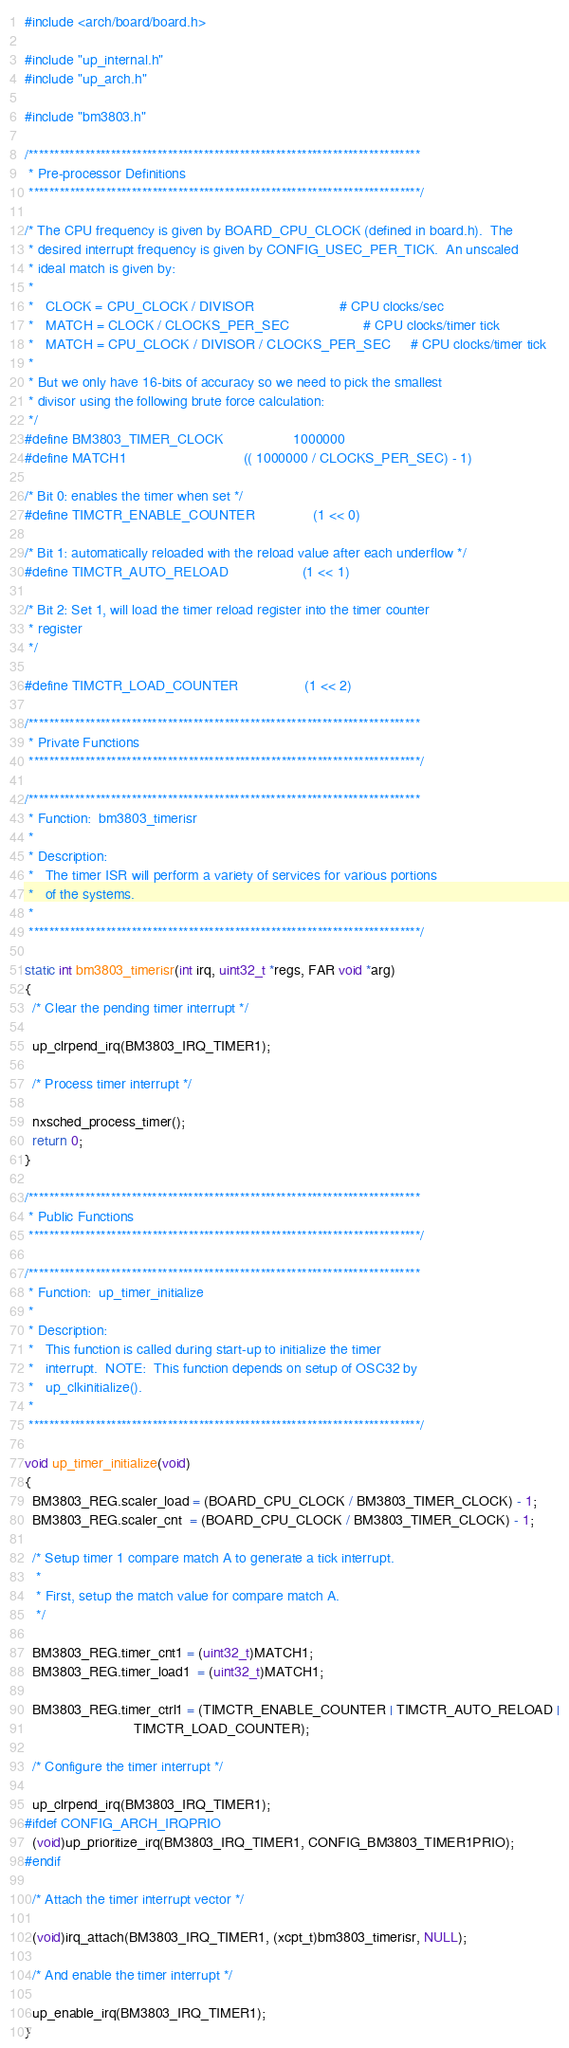Convert code to text. <code><loc_0><loc_0><loc_500><loc_500><_C_>#include <arch/board/board.h>

#include "up_internal.h"
#include "up_arch.h"

#include "bm3803.h"

/****************************************************************************
 * Pre-processor Definitions
 ****************************************************************************/

/* The CPU frequency is given by BOARD_CPU_CLOCK (defined in board.h).  The
 * desired interrupt frequency is given by CONFIG_USEC_PER_TICK.  An unscaled
 * ideal match is given by:
 *
 *   CLOCK = CPU_CLOCK / DIVISOR                      # CPU clocks/sec
 *   MATCH = CLOCK / CLOCKS_PER_SEC                   # CPU clocks/timer tick
 *   MATCH = CPU_CLOCK / DIVISOR / CLOCKS_PER_SEC     # CPU clocks/timer tick
 *
 * But we only have 16-bits of accuracy so we need to pick the smallest
 * divisor using the following brute force calculation:
 */
#define BM3803_TIMER_CLOCK                  1000000
#define MATCH1                              (( 1000000 / CLOCKS_PER_SEC) - 1)

/* Bit 0: enables the timer when set */
#define TIMCTR_ENABLE_COUNTER               (1 << 0)

/* Bit 1: automatically reloaded with the reload value after each underflow */
#define TIMCTR_AUTO_RELOAD            	    (1 << 1)

/* Bit 2: Set 1, will load the timer reload register into the timer counter
 * register
 */

#define TIMCTR_LOAD_COUNTER                 (1 << 2)

/****************************************************************************
 * Private Functions
 ****************************************************************************/

/****************************************************************************
 * Function:  bm3803_timerisr
 *
 * Description:
 *   The timer ISR will perform a variety of services for various portions
 *   of the systems.
 *
 ****************************************************************************/

static int bm3803_timerisr(int irq, uint32_t *regs, FAR void *arg)
{
  /* Clear the pending timer interrupt */

  up_clrpend_irq(BM3803_IRQ_TIMER1);

  /* Process timer interrupt */

  nxsched_process_timer();
  return 0;
}

/****************************************************************************
 * Public Functions
 ****************************************************************************/

/****************************************************************************
 * Function:  up_timer_initialize
 *
 * Description:
 *   This function is called during start-up to initialize the timer
 *   interrupt.  NOTE:  This function depends on setup of OSC32 by
 *   up_clkinitialize().
 *
 ****************************************************************************/

void up_timer_initialize(void)
{
  BM3803_REG.scaler_load = (BOARD_CPU_CLOCK / BM3803_TIMER_CLOCK) - 1;
  BM3803_REG.scaler_cnt  = (BOARD_CPU_CLOCK / BM3803_TIMER_CLOCK) - 1;

  /* Setup timer 1 compare match A to generate a tick interrupt.
   *
   * First, setup the match value for compare match A.
   */

  BM3803_REG.timer_cnt1 = (uint32_t)MATCH1;
  BM3803_REG.timer_load1  = (uint32_t)MATCH1;

  BM3803_REG.timer_ctrl1 = (TIMCTR_ENABLE_COUNTER | TIMCTR_AUTO_RELOAD |
                            TIMCTR_LOAD_COUNTER);

  /* Configure the timer interrupt */

  up_clrpend_irq(BM3803_IRQ_TIMER1);
#ifdef CONFIG_ARCH_IRQPRIO
  (void)up_prioritize_irq(BM3803_IRQ_TIMER1, CONFIG_BM3803_TIMER1PRIO);
#endif

  /* Attach the timer interrupt vector */

  (void)irq_attach(BM3803_IRQ_TIMER1, (xcpt_t)bm3803_timerisr, NULL);

  /* And enable the timer interrupt */

  up_enable_irq(BM3803_IRQ_TIMER1);
}
</code> 